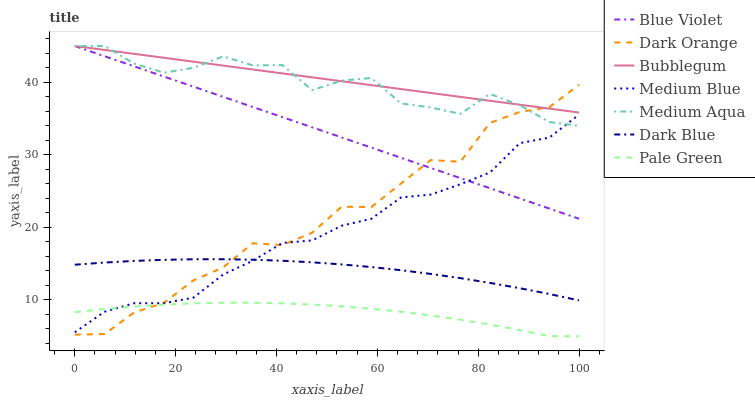Does Pale Green have the minimum area under the curve?
Answer yes or no. Yes. Does Bubblegum have the maximum area under the curve?
Answer yes or no. Yes. Does Medium Blue have the minimum area under the curve?
Answer yes or no. No. Does Medium Blue have the maximum area under the curve?
Answer yes or no. No. Is Blue Violet the smoothest?
Answer yes or no. Yes. Is Dark Orange the roughest?
Answer yes or no. Yes. Is Medium Blue the smoothest?
Answer yes or no. No. Is Medium Blue the roughest?
Answer yes or no. No. Does Pale Green have the lowest value?
Answer yes or no. Yes. Does Medium Blue have the lowest value?
Answer yes or no. No. Does Blue Violet have the highest value?
Answer yes or no. Yes. Does Medium Blue have the highest value?
Answer yes or no. No. Is Dark Blue less than Medium Aqua?
Answer yes or no. Yes. Is Bubblegum greater than Dark Blue?
Answer yes or no. Yes. Does Medium Aqua intersect Blue Violet?
Answer yes or no. Yes. Is Medium Aqua less than Blue Violet?
Answer yes or no. No. Is Medium Aqua greater than Blue Violet?
Answer yes or no. No. Does Dark Blue intersect Medium Aqua?
Answer yes or no. No. 